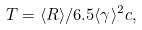Convert formula to latex. <formula><loc_0><loc_0><loc_500><loc_500>T = \langle R \rangle / 6 . 5 \langle \gamma \rangle ^ { 2 } c ,</formula> 